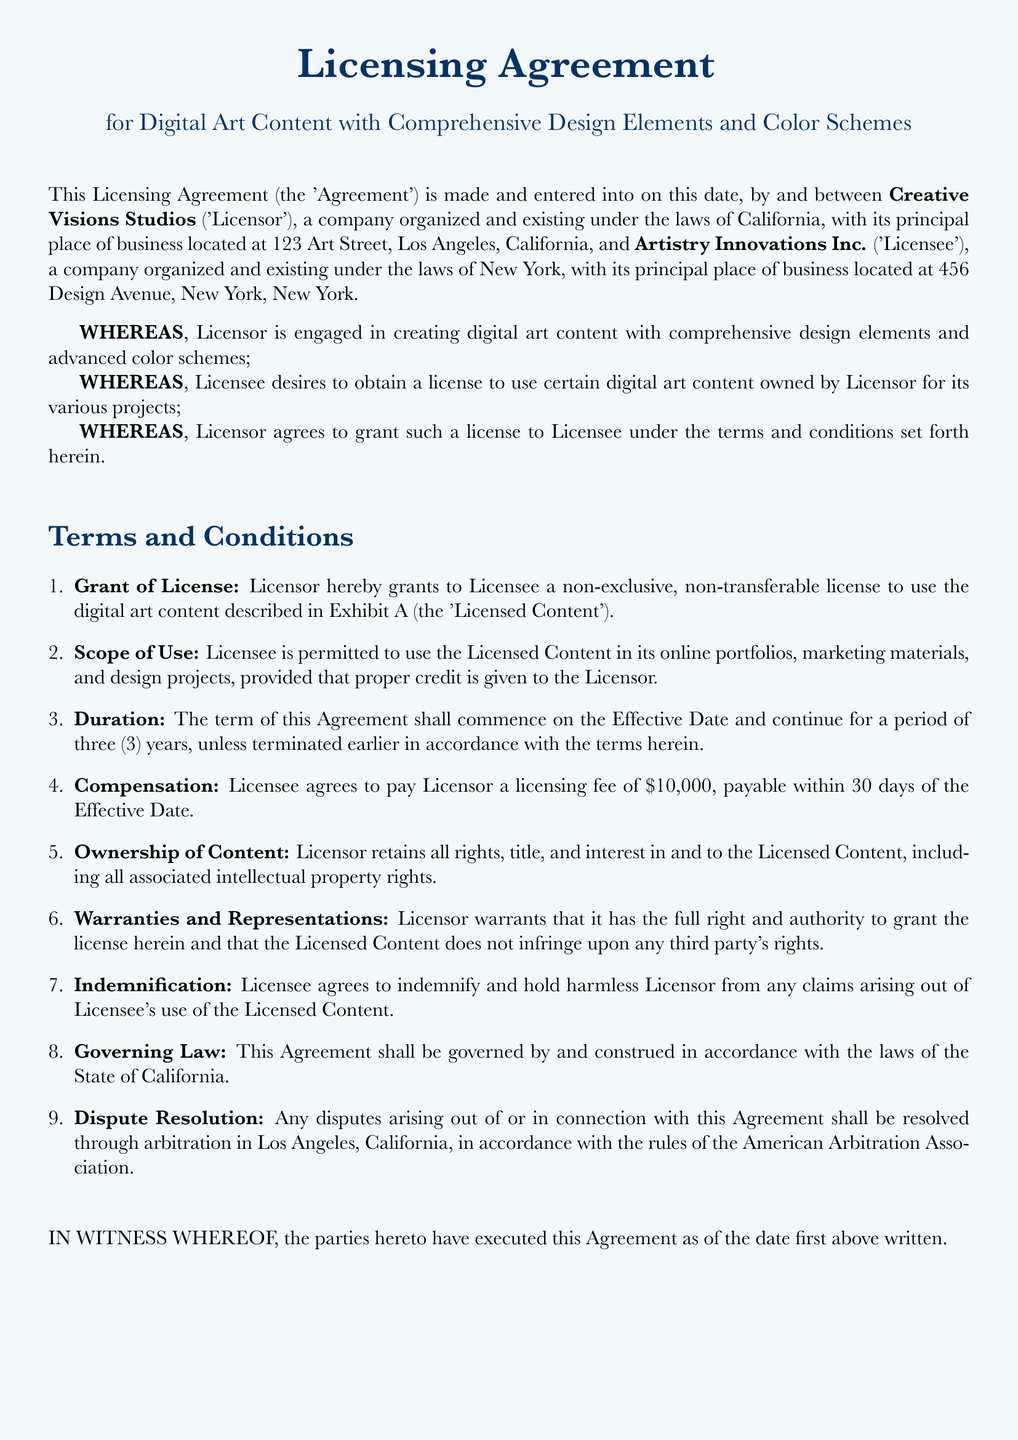What is the license type granted? The agreement specifies a non-exclusive, non-transferable license for the use of digital art content.
Answer: non-exclusive, non-transferable Who are the parties involved in the agreement? The agreement mentions Creative Visions Studios as the Licensor and Artistry Innovations Inc. as the Licensee.
Answer: Creative Visions Studios and Artistry Innovations Inc What is the licensing fee amount? The document states that the licensing fee to be paid by the Licensee is $10,000.
Answer: $10,000 For how long is the license valid? The duration of the license as mentioned in the agreement is for a period of three years.
Answer: three years What are the governing laws for the agreement? The document specifies that the agreement shall be governed by the laws of the State of California.
Answer: State of California What is required in terms of credit when using the Licensed Content? The Licensee is required to give proper credit to the Licensor when using the Licensed Content as per the scope of use.
Answer: proper credit Who signs the document as Creative Director? The document indicates that Alexandra Finch signs as the Creative Director for Creative Visions Studios.
Answer: Alexandra Finch What is the location for dispute resolution? According to the agreement, any disputes shall be resolved in Los Angeles, California.
Answer: Los Angeles, California What must the Licensee do regarding claims from the use of Licensed Content? The Licensee agrees to indemnify and hold harmless the Licensor from any claims arising out of the use of the Licensed Content.
Answer: indemnify and hold harmless 